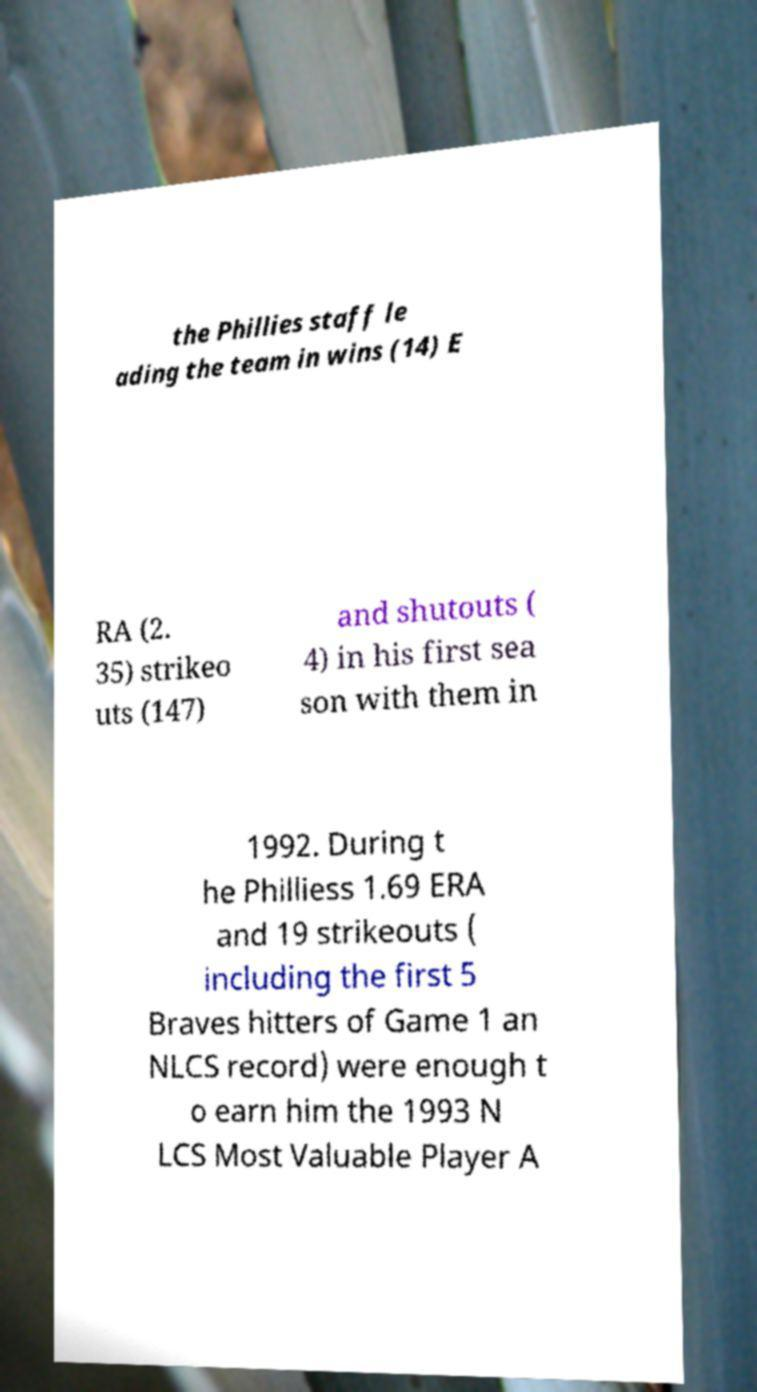I need the written content from this picture converted into text. Can you do that? the Phillies staff le ading the team in wins (14) E RA (2. 35) strikeo uts (147) and shutouts ( 4) in his first sea son with them in 1992. During t he Philliess 1.69 ERA and 19 strikeouts ( including the first 5 Braves hitters of Game 1 an NLCS record) were enough t o earn him the 1993 N LCS Most Valuable Player A 